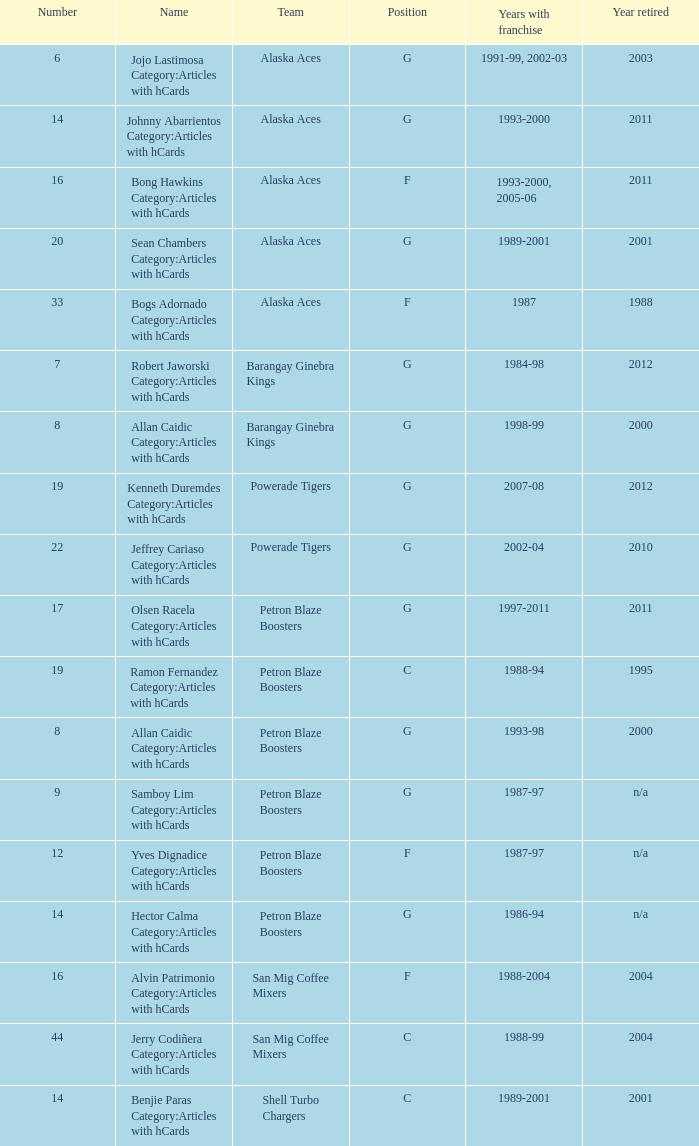Which unit is placed 14th and possessed a franchise from 1993 to 2000? Alaska Aces. 